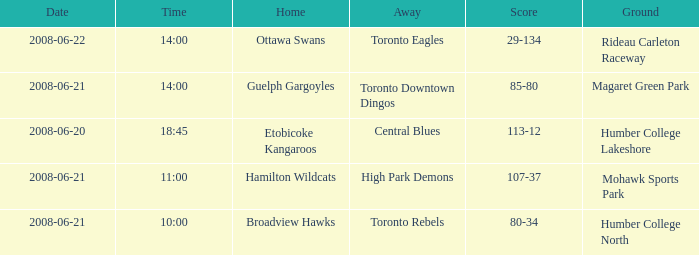What does "away with a ground" mean in relation to humber college north? Toronto Rebels. 